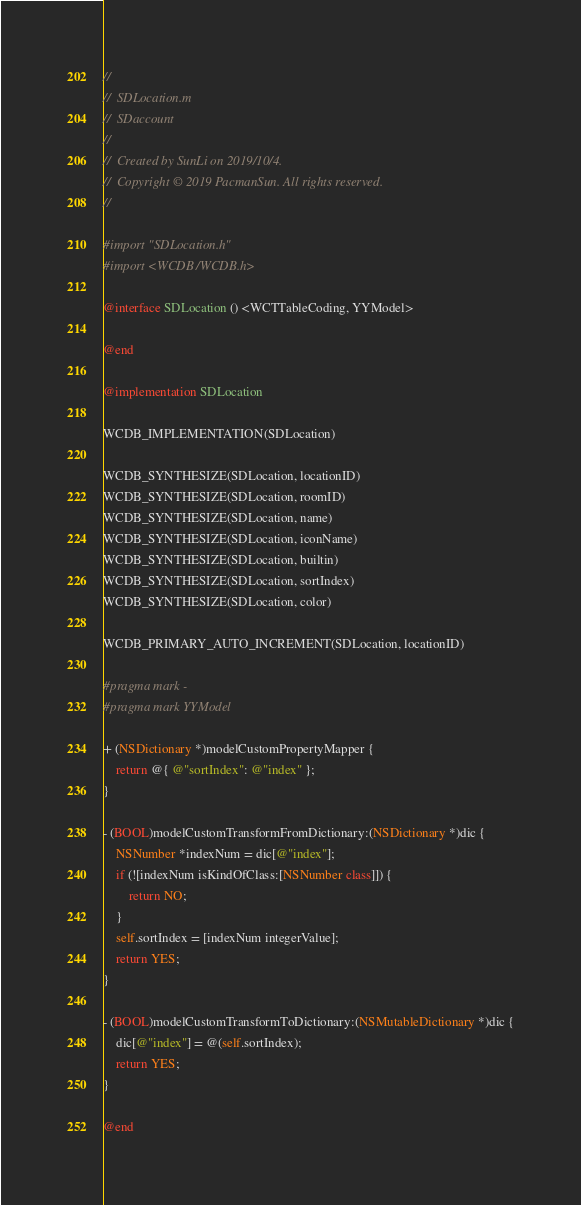<code> <loc_0><loc_0><loc_500><loc_500><_ObjectiveC_>//
//  SDLocation.m
//  SDaccount
//
//  Created by SunLi on 2019/10/4.
//  Copyright © 2019 PacmanSun. All rights reserved.
//

#import "SDLocation.h"
#import <WCDB/WCDB.h>

@interface SDLocation () <WCTTableCoding, YYModel>

@end

@implementation SDLocation

WCDB_IMPLEMENTATION(SDLocation)

WCDB_SYNTHESIZE(SDLocation, locationID)
WCDB_SYNTHESIZE(SDLocation, roomID)
WCDB_SYNTHESIZE(SDLocation, name)
WCDB_SYNTHESIZE(SDLocation, iconName)
WCDB_SYNTHESIZE(SDLocation, builtin)
WCDB_SYNTHESIZE(SDLocation, sortIndex)
WCDB_SYNTHESIZE(SDLocation, color)

WCDB_PRIMARY_AUTO_INCREMENT(SDLocation, locationID)

#pragma mark -
#pragma mark YYModel

+ (NSDictionary *)modelCustomPropertyMapper {
    return @{ @"sortIndex": @"index" };
}

- (BOOL)modelCustomTransformFromDictionary:(NSDictionary *)dic {
    NSNumber *indexNum = dic[@"index"];
    if (![indexNum isKindOfClass:[NSNumber class]]) {
        return NO;
    }
    self.sortIndex = [indexNum integerValue];
    return YES;
}

- (BOOL)modelCustomTransformToDictionary:(NSMutableDictionary *)dic {
    dic[@"index"] = @(self.sortIndex);
    return YES;
}

@end
</code> 